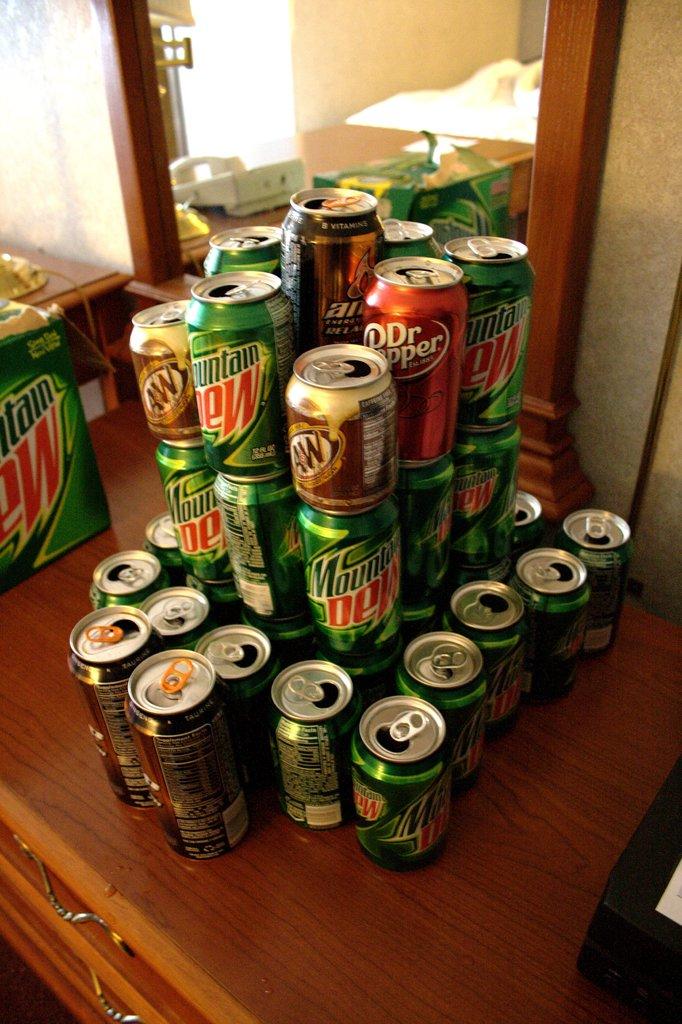What flavor of soda is in the green cans?
Provide a short and direct response. Mountain dew. What kind of soda is in the green can?
Ensure brevity in your answer.  Mountain dew. 